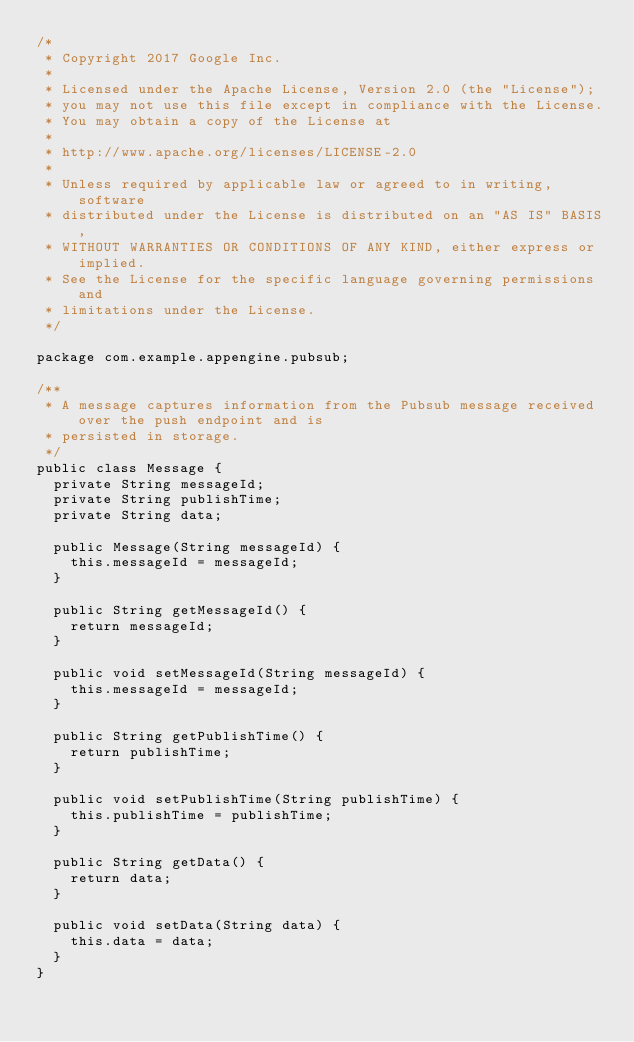<code> <loc_0><loc_0><loc_500><loc_500><_Java_>/*
 * Copyright 2017 Google Inc.
 *
 * Licensed under the Apache License, Version 2.0 (the "License");
 * you may not use this file except in compliance with the License.
 * You may obtain a copy of the License at
 *
 * http://www.apache.org/licenses/LICENSE-2.0
 *
 * Unless required by applicable law or agreed to in writing, software
 * distributed under the License is distributed on an "AS IS" BASIS,
 * WITHOUT WARRANTIES OR CONDITIONS OF ANY KIND, either express or implied.
 * See the License for the specific language governing permissions and
 * limitations under the License.
 */

package com.example.appengine.pubsub;

/**
 * A message captures information from the Pubsub message received over the push endpoint and is
 * persisted in storage.
 */
public class Message {
  private String messageId;
  private String publishTime;
  private String data;

  public Message(String messageId) {
    this.messageId = messageId;
  }

  public String getMessageId() {
    return messageId;
  }

  public void setMessageId(String messageId) {
    this.messageId = messageId;
  }

  public String getPublishTime() {
    return publishTime;
  }

  public void setPublishTime(String publishTime) {
    this.publishTime = publishTime;
  }

  public String getData() {
    return data;
  }

  public void setData(String data) {
    this.data = data;
  }
}
</code> 